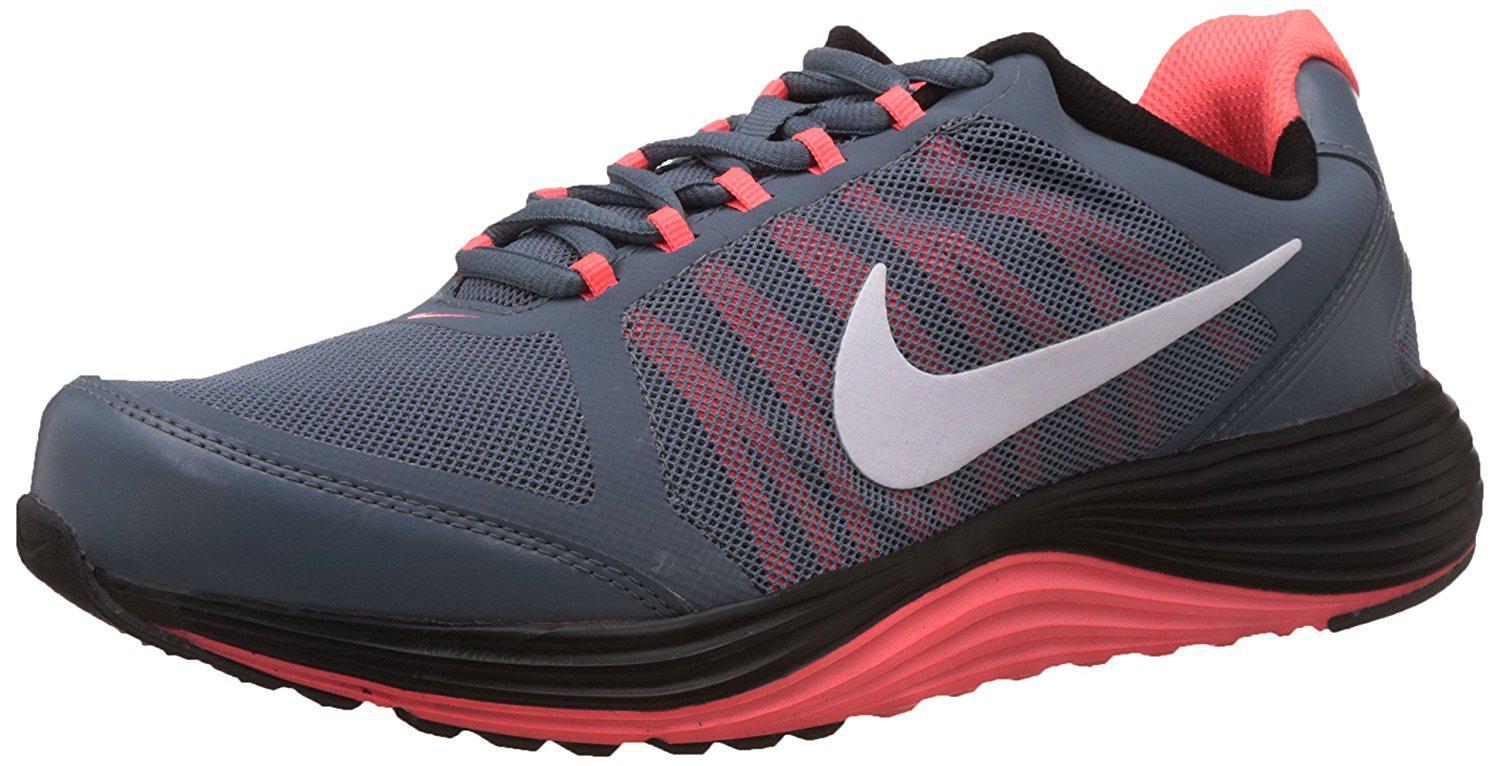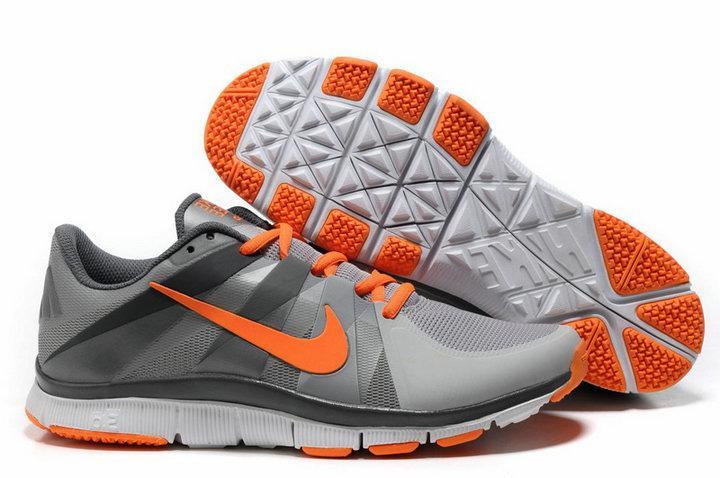The first image is the image on the left, the second image is the image on the right. For the images shown, is this caption "One image features an orange shoe with a gray sole." true? Answer yes or no. No. The first image is the image on the left, the second image is the image on the right. For the images shown, is this caption "There is exactly one shoe in the image on the right." true? Answer yes or no. No. 